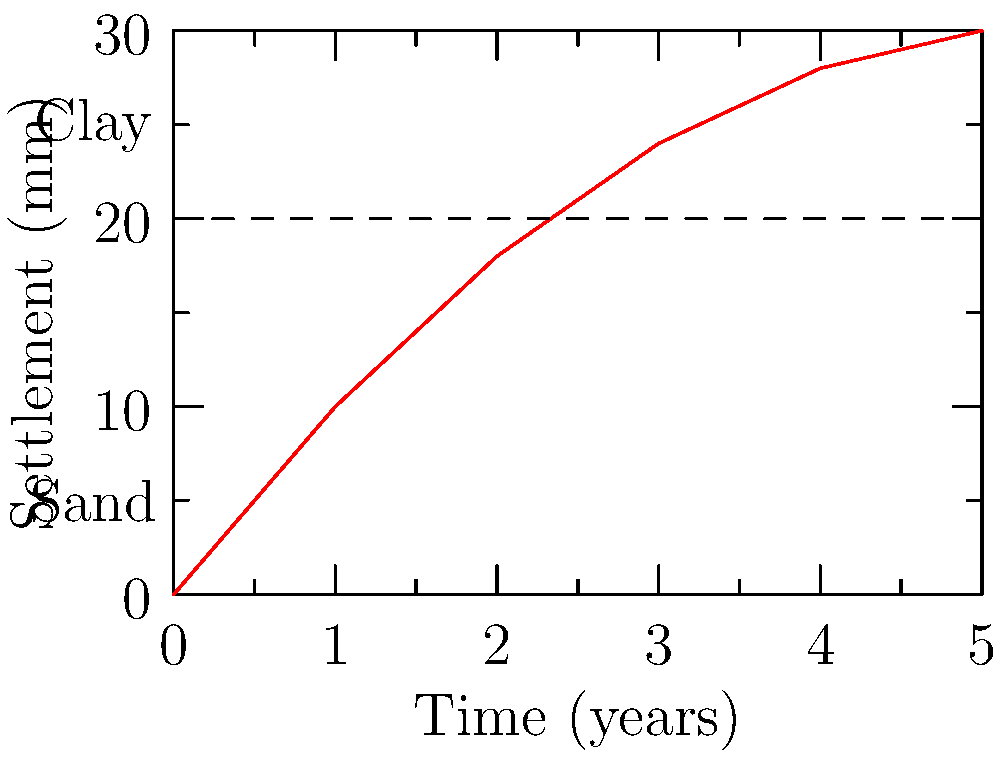The graph shows the settlement of a building foundation over time in two different soil types. The dashed line represents the interface between clay and sand layers. Based on this information, calculate the rate of settlement (in mm/year) for the first two years and compare it to the rate for the last two years. What does this indicate about the long-term behavior of the foundation? To solve this problem, we'll follow these steps:

1. Calculate the rate of settlement for the first two years:
   - Settlement at 0 years: 0 mm
   - Settlement at 2 years: 18 mm
   - Time period: 2 years
   - Rate = (18 mm - 0 mm) / 2 years = 9 mm/year

2. Calculate the rate of settlement for the last two years:
   - Settlement at 3 years: 24 mm
   - Settlement at 5 years: 30 mm
   - Time period: 2 years
   - Rate = (30 mm - 24 mm) / 2 years = 3 mm/year

3. Compare the rates:
   - Initial rate (0-2 years): 9 mm/year
   - Later rate (3-5 years): 3 mm/year

4. Analyze the long-term behavior:
   - The rate of settlement is decreasing over time
   - This indicates that the foundation is approaching a state of equilibrium
   - The clay layer (upper part) experiences more rapid initial settlement due to its compressibility
   - The sand layer (lower part) provides more stability and limits further settlement

5. Long-term implications:
   - The foundation is likely to stabilize over time
   - Most of the settlement occurs in the early years after construction
   - Future settlement is expected to be minimal

This behavior is typical for foundations on layered soils, where the more compressible layer (clay) contributes to initial rapid settlement, followed by a slower, more stable period as the load is transferred to the less compressible layer (sand).
Answer: The settlement rate decreases from 9 mm/year to 3 mm/year, indicating the foundation is approaching equilibrium and will likely stabilize over time. 